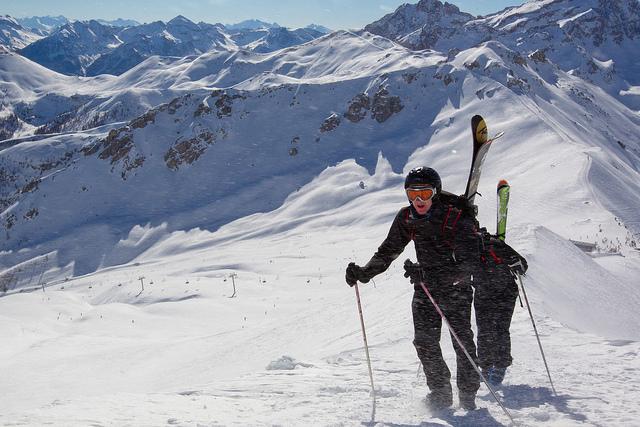How many people are in the snow?
Keep it brief. 2. Does the woman appear happy?
Keep it brief. No. What are on their backs?
Be succinct. Skis. Is most of this snow pristine?
Concise answer only. Yes. 